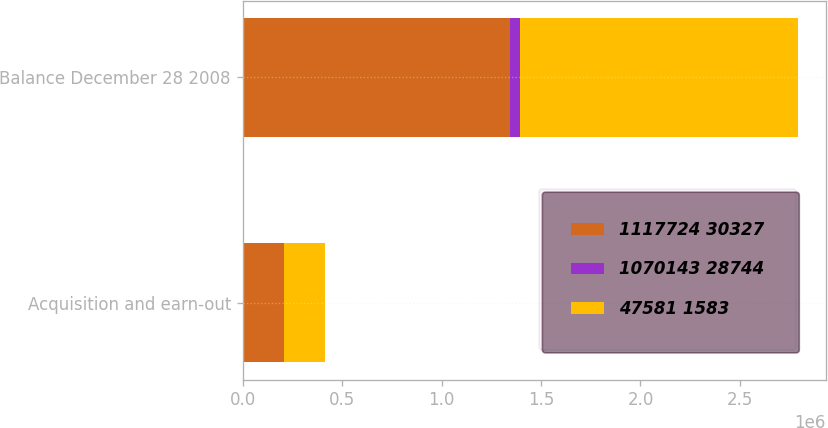Convert chart. <chart><loc_0><loc_0><loc_500><loc_500><stacked_bar_chart><ecel><fcel>Acquisition and earn-out<fcel>Balance December 28 2008<nl><fcel>1117724 30327<fcel>208196<fcel>1.34544e+06<nl><fcel>1070143 28744<fcel>591<fcel>50850<nl><fcel>47581 1583<fcel>207605<fcel>1.39629e+06<nl></chart> 